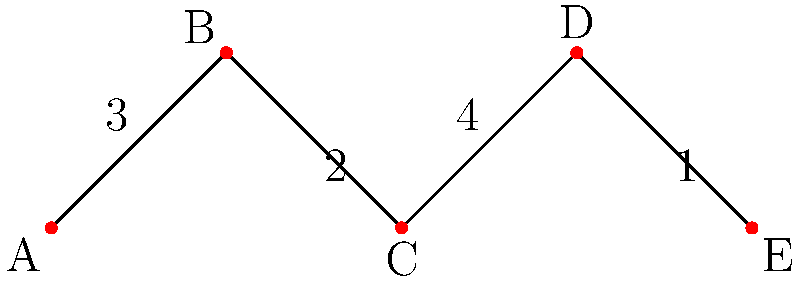In the graph above, cities A, B, C, D, and E represent major European cities. The edges represent direct connections between cities, and the numbers on the edges indicate the number of shared places of worship between connected cities. What is the minimum number of cities that need to be visited to ensure all types of places of worship are seen, assuming each city has at least one unique place of worship not found in the others? To solve this problem, we need to follow these steps:

1. Understand the graph:
   - Each vertex (A, B, C, D, E) represents a major European city.
   - Each edge represents a connection between cities.
   - The number on each edge represents the number of shared places of worship.

2. Analyze the connections:
   - A-B: 3 shared places of worship
   - B-C: 2 shared places of worship
   - C-D: 4 shared places of worship
   - D-E: 1 shared place of worship

3. Consider the unique places of worship:
   - Each city has at least one unique place of worship.

4. Find the minimum number of cities to visit:
   - Start with any city, let's choose A.
   - A has all its unique places of worship, plus 3 shared with B.
   - We need to visit B to see its unique place(s) of worship.
   - B shares 2 with C, so we need to visit C for its unique place(s).
   - C shares 4 with D, so we need to visit D for its unique place(s).
   - D shares 1 with E, so we need to visit E for its unique place(s).

5. Conclusion:
   - We need to visit all 5 cities to ensure we see all types of places of worship.

This approach ensures that we see all unique places of worship in each city, as well as all shared ones.
Answer: 5 cities 